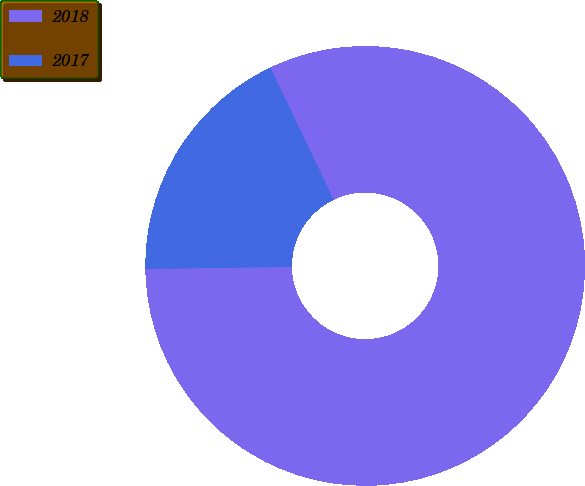<chart> <loc_0><loc_0><loc_500><loc_500><pie_chart><fcel>2018<fcel>2017<nl><fcel>81.88%<fcel>18.12%<nl></chart> 